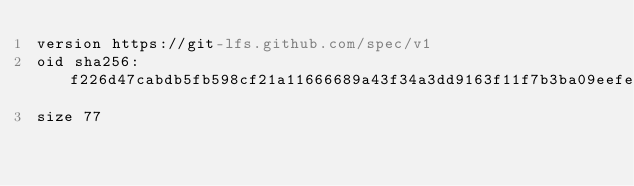<code> <loc_0><loc_0><loc_500><loc_500><_YAML_>version https://git-lfs.github.com/spec/v1
oid sha256:f226d47cabdb5fb598cf21a11666689a43f34a3dd9163f11f7b3ba09eefed1c2
size 77
</code> 